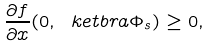Convert formula to latex. <formula><loc_0><loc_0><loc_500><loc_500>\frac { \partial f } { \partial x } ( 0 , \ k e t b r a { \Phi _ { s } } ) \geq 0 ,</formula> 